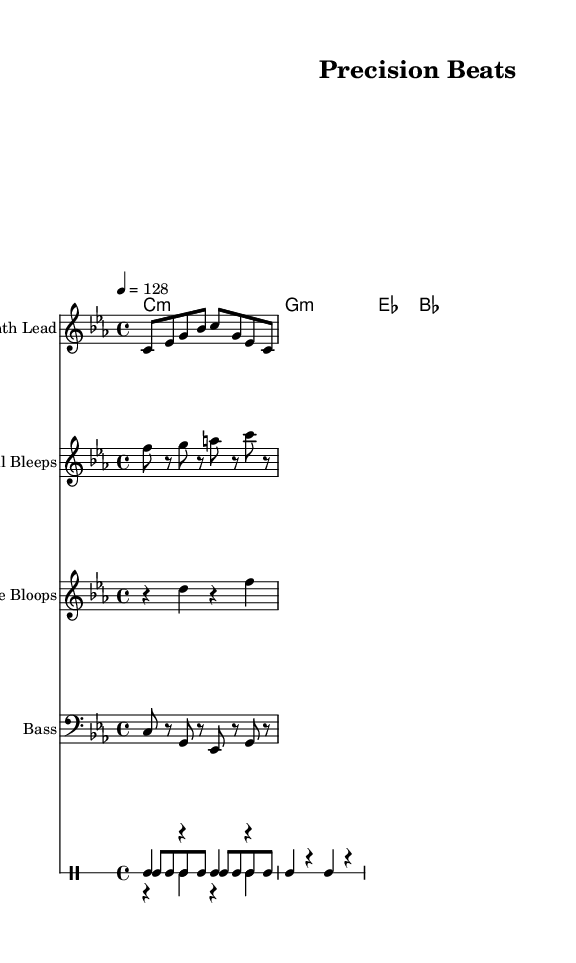What is the key signature of this music? The key signature is C minor, indicated by three flats in the key signature at the beginning of the staff.
Answer: C minor What is the time signature of this piece? The time signature is 4/4, which is shown at the start of the score, indicating four beats per measure and a quarter note receives one beat.
Answer: 4/4 What is the tempo marking for this piece? The tempo marking is 128 beats per minute, specified in the tempo directive at the beginning of the score.
Answer: 128 How many measures are in the bass line? The bass line consists of four measures, as determined by counting the bars in the bass section of the score.
Answer: 4 What types of instruments are used in this music? The music features a drum set, synth lead, digital bleeps, interface bloops, and bass, all indicated by their corresponding staves in the score.
Answer: Drum set, synth lead, digital bleeps, interface bloops, bass Which instrument plays the digital bleep sounds? The digital bleeps are played by the staff labeled "Digital Bleeps" in the score, which shows their specific musical notes.
Answer: Digital Bleeps 